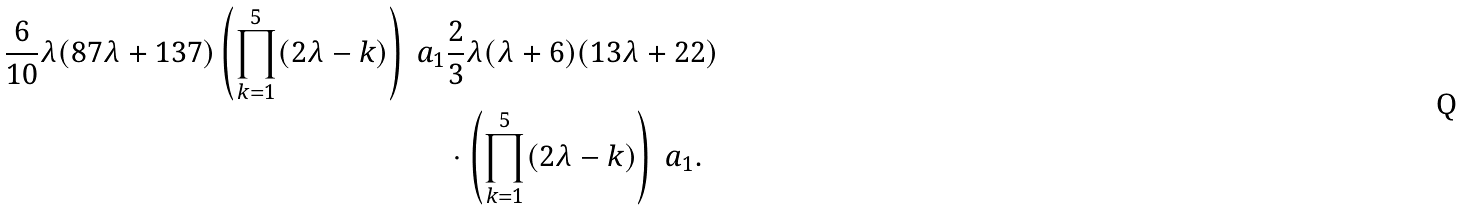Convert formula to latex. <formula><loc_0><loc_0><loc_500><loc_500>\frac { 6 } { 1 0 } \lambda ( 8 7 \lambda + 1 3 7 ) \left ( \prod _ { k = 1 } ^ { 5 } ( 2 \lambda - k ) \right ) \ a _ { 1 } & \frac { 2 } { 3 } \lambda ( \lambda + 6 ) ( 1 3 \lambda + 2 2 ) \\ & \cdot \left ( \prod _ { k = 1 } ^ { 5 } ( 2 \lambda - k ) \right ) \ a _ { 1 } .</formula> 